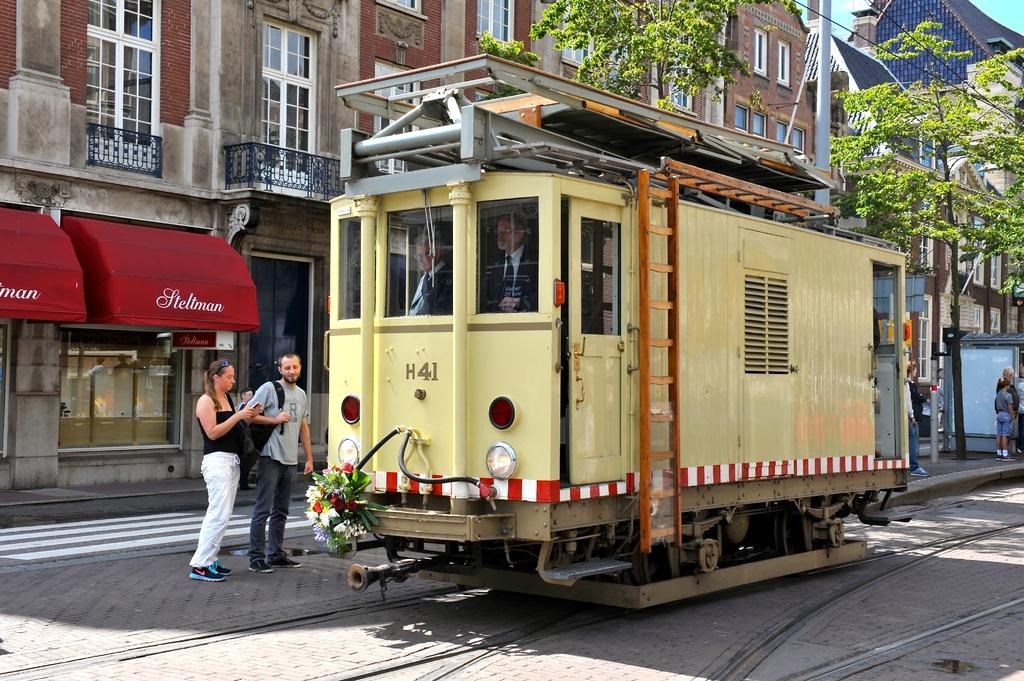What is the main subject of the image? The main subject of the image is a train. Can you describe the people inside the train? There are two persons inside the train. What is happening with the people near the train? There are people standing near the train. What type of natural scenery can be seen in the image? There are trees visible in the image. What can be seen in the background of the image? There are buildings in the background of the image. What type of vegetable is being used as a prop by the cast in the image? There is no vegetable or cast present in the image; it features a train with people inside and near it. 